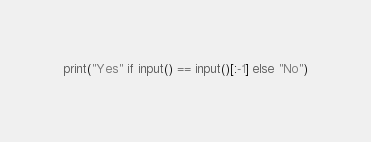Convert code to text. <code><loc_0><loc_0><loc_500><loc_500><_Python_>print("Yes" if input() == input()[:-1] else "No")
</code> 